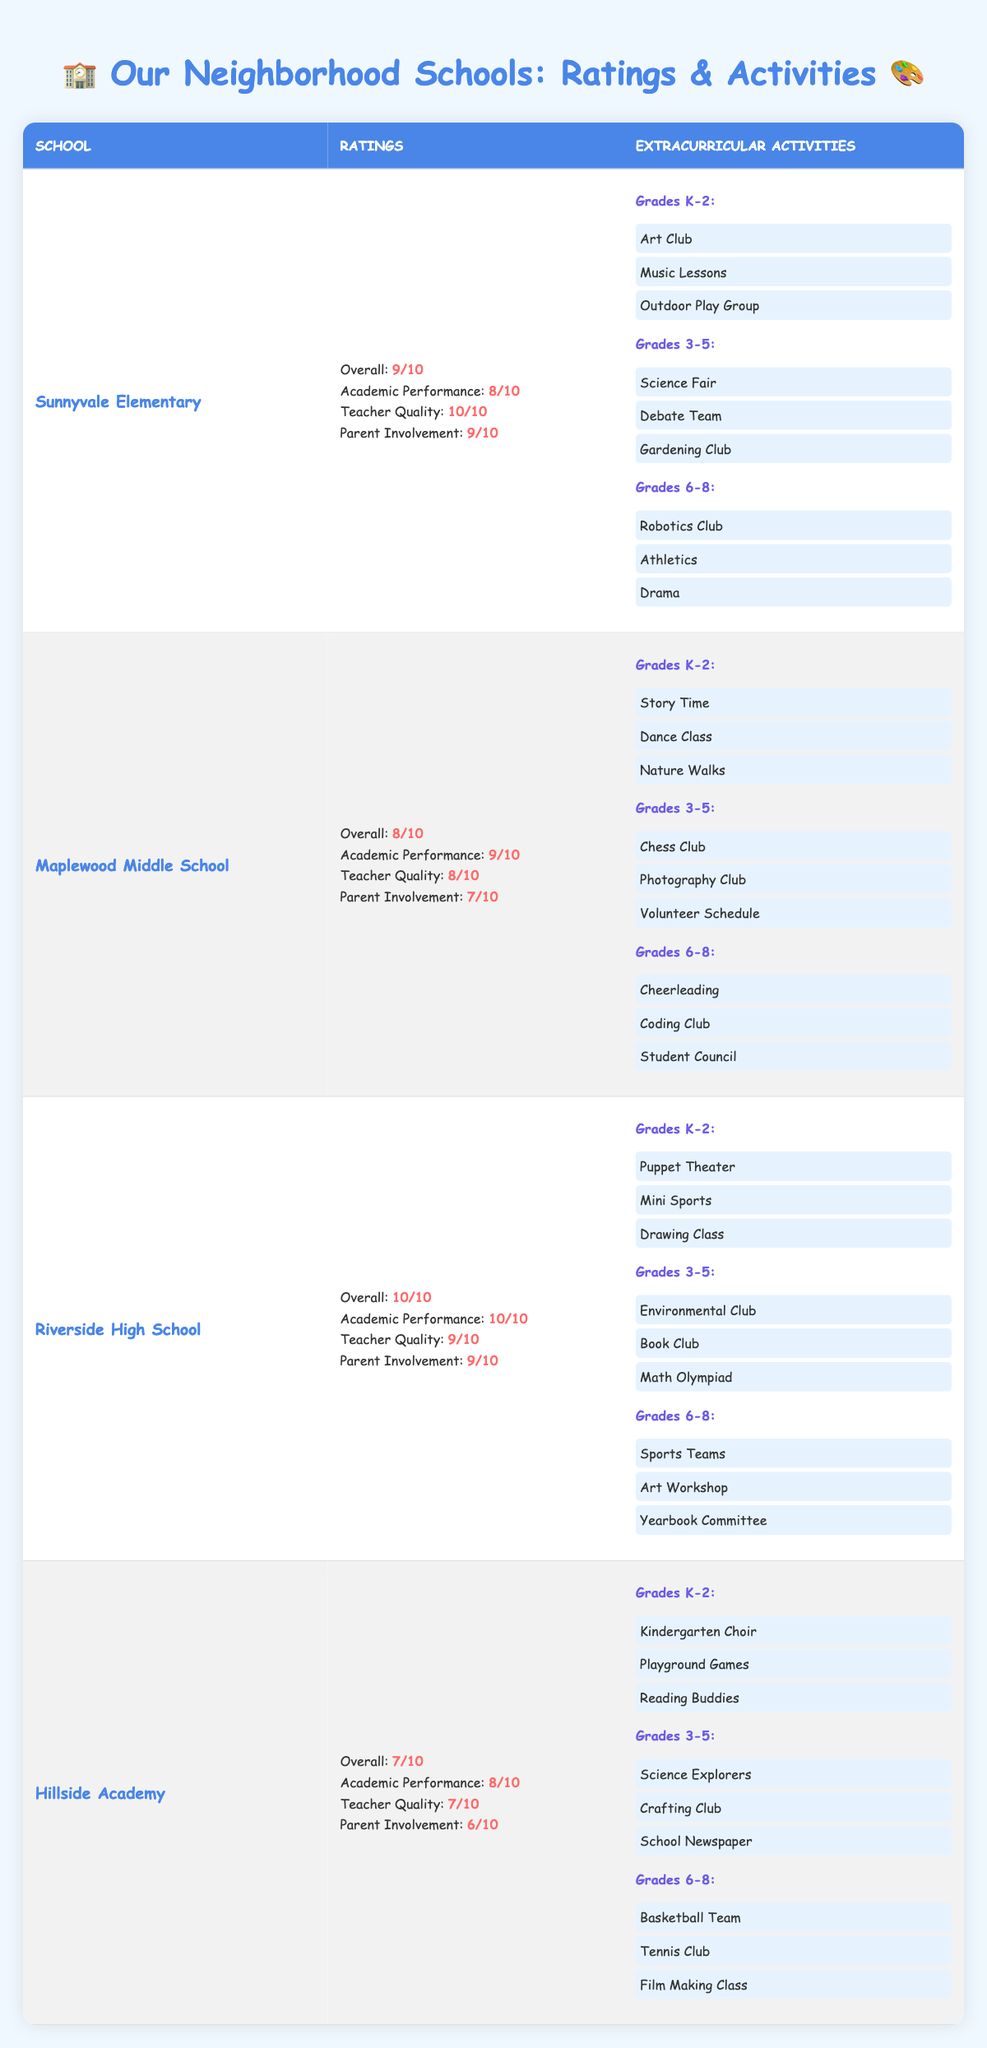What is the overall rating of Riverside High School? Riverside High School has an overall rating listed in the table, which is 10 out of 10.
Answer: 10 Which school has the highest academic performance rating? The table shows Riverside High School with an academic performance rating of 10, which is the highest among all schools listed.
Answer: Riverside High School Does Hillside Academy have a better parent involvement rating compared to Maplewood Middle School? Hillside Academy has a parent involvement rating of 6, while Maplewood Middle School has a rating of 7. Since 7 is greater than 6, Hillside does not have a better rating.
Answer: No How many extracurricular activities are available for grades 3-5 at Sunnyvale Elementary? The table lists three extracurricular activities for grades 3-5 at Sunnyvale Elementary: Science Fair, Debate Team, and Gardening Club. Thus, there are three activities in total.
Answer: 3 What is the difference between the overall ratings of Sunnyvale Elementary and Hillside Academy? Sunnyvale Elementary has an overall rating of 9, while Hillside Academy has a rating of 7. The difference is 9 - 7 = 2.
Answer: 2 Which school offers the most extracurricular activities for grades K-2? When counting the activities, Sunnyvale Elementary has 3 (Art Club, Music Lessons, Outdoor Play Group), Maplewood Middle School also has 3 (Story Time, Dance Class, Nature Walks), Riverside High School has 3 (Puppet Theater, Mini Sports, Drawing Class), and Hillside Academy has 3 (Kindergarten Choir, Playground Games, Reading Buddies). Hence, none offers more than 3, they are all equal.
Answer: None (all schools offer the same) Is there a club or activity related to technology available for grades 6-8 at any school? Looking at the activities listed for grades 6-8, Maplewood Middle School includes a Coding Club, and Riverside High School offers Robotics Club, which are both related to technology.
Answer: Yes What is the average overall rating of the four schools listed? To find the average, we sum the overall ratings: 9 (Sunnyvale) + 8 (Maplewood) + 10 (Riverside) + 7 (Hillside) = 34. There are 4 schools, so the average is 34 / 4 = 8.5.
Answer: 8.5 Which school has the lowest teacher quality rating? Hillside Academy has the lowest teacher quality rating of 7 compared to others, Sunnyvale Elementary (10), Maplewood Middle School (8), and Riverside High School (9).
Answer: Hillside Academy Are there any schools where grades K-2 can participate in dance-related activities? The activities for grades K-2 include Dance Class at Maplewood Middle School, meaning it does have dance-related activities for that grade level.
Answer: Yes 